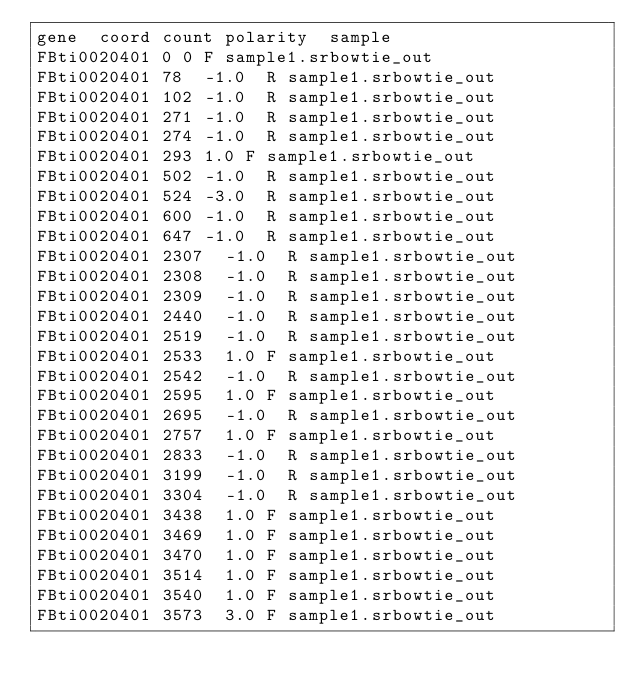<code> <loc_0><loc_0><loc_500><loc_500><_SQL_>gene	coord	count	polarity	sample
FBti0020401	0	0	F	sample1.srbowtie_out
FBti0020401	78	-1.0	R	sample1.srbowtie_out
FBti0020401	102	-1.0	R	sample1.srbowtie_out
FBti0020401	271	-1.0	R	sample1.srbowtie_out
FBti0020401	274	-1.0	R	sample1.srbowtie_out
FBti0020401	293	1.0	F	sample1.srbowtie_out
FBti0020401	502	-1.0	R	sample1.srbowtie_out
FBti0020401	524	-3.0	R	sample1.srbowtie_out
FBti0020401	600	-1.0	R	sample1.srbowtie_out
FBti0020401	647	-1.0	R	sample1.srbowtie_out
FBti0020401	2307	-1.0	R	sample1.srbowtie_out
FBti0020401	2308	-1.0	R	sample1.srbowtie_out
FBti0020401	2309	-1.0	R	sample1.srbowtie_out
FBti0020401	2440	-1.0	R	sample1.srbowtie_out
FBti0020401	2519	-1.0	R	sample1.srbowtie_out
FBti0020401	2533	1.0	F	sample1.srbowtie_out
FBti0020401	2542	-1.0	R	sample1.srbowtie_out
FBti0020401	2595	1.0	F	sample1.srbowtie_out
FBti0020401	2695	-1.0	R	sample1.srbowtie_out
FBti0020401	2757	1.0	F	sample1.srbowtie_out
FBti0020401	2833	-1.0	R	sample1.srbowtie_out
FBti0020401	3199	-1.0	R	sample1.srbowtie_out
FBti0020401	3304	-1.0	R	sample1.srbowtie_out
FBti0020401	3438	1.0	F	sample1.srbowtie_out
FBti0020401	3469	1.0	F	sample1.srbowtie_out
FBti0020401	3470	1.0	F	sample1.srbowtie_out
FBti0020401	3514	1.0	F	sample1.srbowtie_out
FBti0020401	3540	1.0	F	sample1.srbowtie_out
FBti0020401	3573	3.0	F	sample1.srbowtie_out</code> 